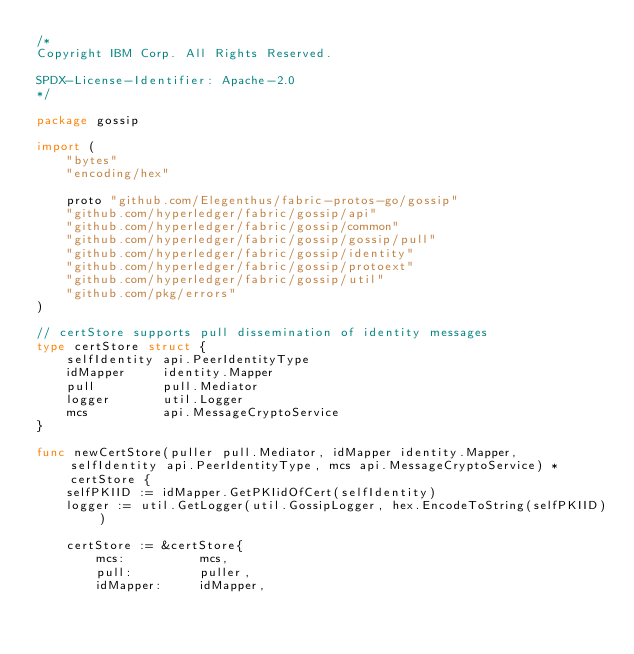Convert code to text. <code><loc_0><loc_0><loc_500><loc_500><_Go_>/*
Copyright IBM Corp. All Rights Reserved.

SPDX-License-Identifier: Apache-2.0
*/

package gossip

import (
	"bytes"
	"encoding/hex"

	proto "github.com/Elegenthus/fabric-protos-go/gossip"
	"github.com/hyperledger/fabric/gossip/api"
	"github.com/hyperledger/fabric/gossip/common"
	"github.com/hyperledger/fabric/gossip/gossip/pull"
	"github.com/hyperledger/fabric/gossip/identity"
	"github.com/hyperledger/fabric/gossip/protoext"
	"github.com/hyperledger/fabric/gossip/util"
	"github.com/pkg/errors"
)

// certStore supports pull dissemination of identity messages
type certStore struct {
	selfIdentity api.PeerIdentityType
	idMapper     identity.Mapper
	pull         pull.Mediator
	logger       util.Logger
	mcs          api.MessageCryptoService
}

func newCertStore(puller pull.Mediator, idMapper identity.Mapper, selfIdentity api.PeerIdentityType, mcs api.MessageCryptoService) *certStore {
	selfPKIID := idMapper.GetPKIidOfCert(selfIdentity)
	logger := util.GetLogger(util.GossipLogger, hex.EncodeToString(selfPKIID))

	certStore := &certStore{
		mcs:          mcs,
		pull:         puller,
		idMapper:     idMapper,</code> 